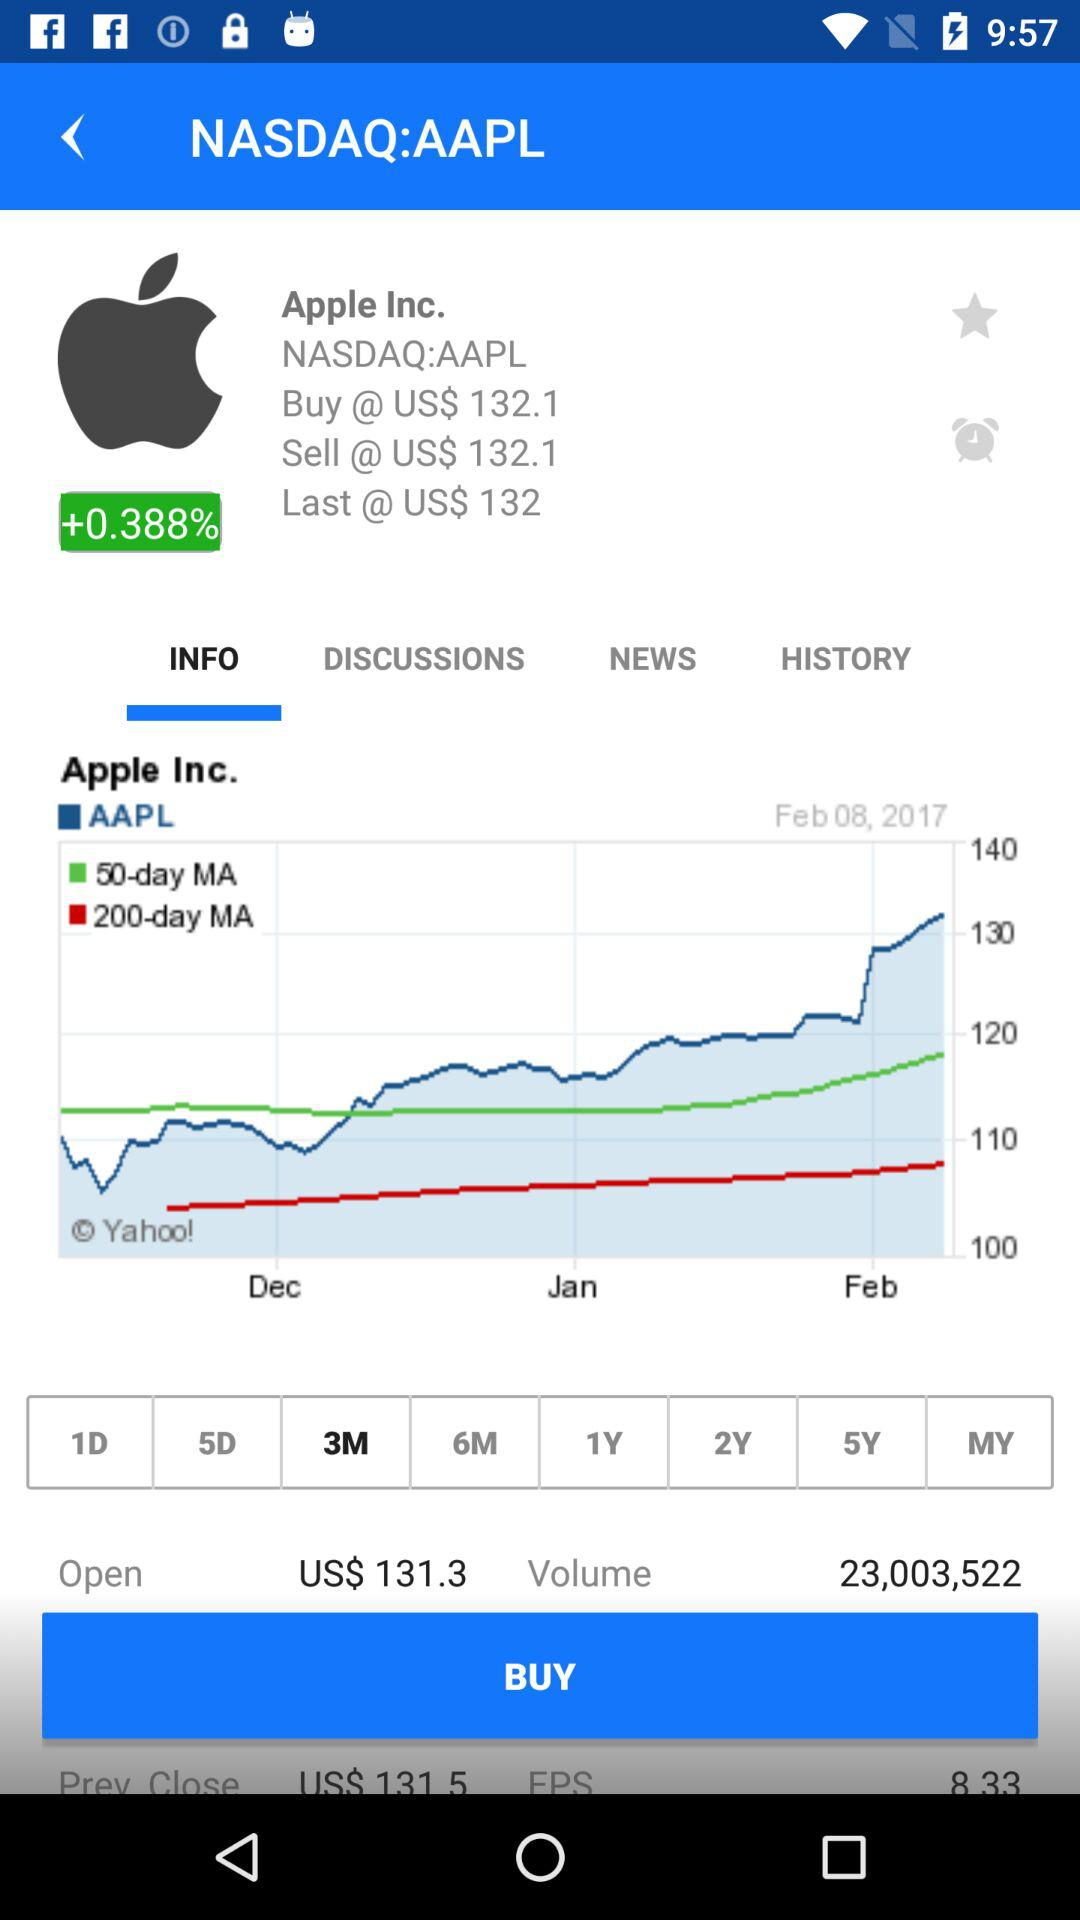How much of a percentage has increased on Apple? The increased percentage is +0.388. 